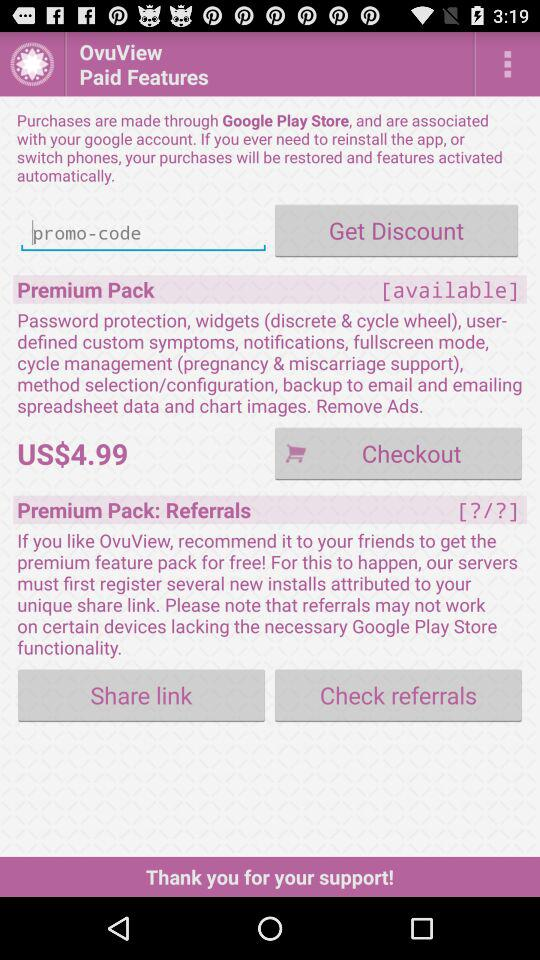How much do I have to pay to get a premium pack? You have to pay US$4.99 to get a premium pack. 